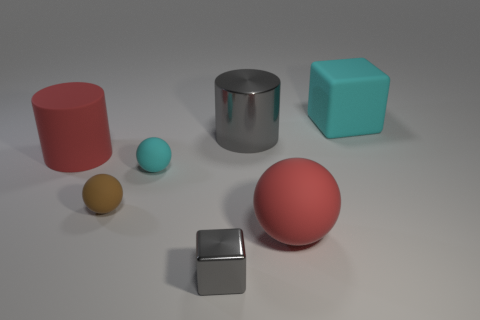The big red thing to the left of the brown sphere has what shape?
Provide a short and direct response. Cylinder. What number of rubber objects are the same size as the red cylinder?
Provide a short and direct response. 2. Is the color of the shiny thing that is on the left side of the large gray object the same as the metallic cylinder?
Provide a succinct answer. Yes. There is a thing that is both behind the rubber cylinder and left of the large cube; what material is it?
Give a very brief answer. Metal. Is the number of small gray metal things greater than the number of tiny rubber spheres?
Ensure brevity in your answer.  No. The cube left of the block that is behind the cyan rubber thing that is on the left side of the big rubber cube is what color?
Your answer should be very brief. Gray. Do the gray cube that is in front of the cyan rubber sphere and the large gray object have the same material?
Provide a succinct answer. Yes. Is there a block of the same color as the big metallic thing?
Keep it short and to the point. Yes. Is there a brown rubber thing?
Your response must be concise. Yes. There is a cyan thing that is left of the red matte ball; is its size the same as the red matte cylinder?
Make the answer very short. No. 